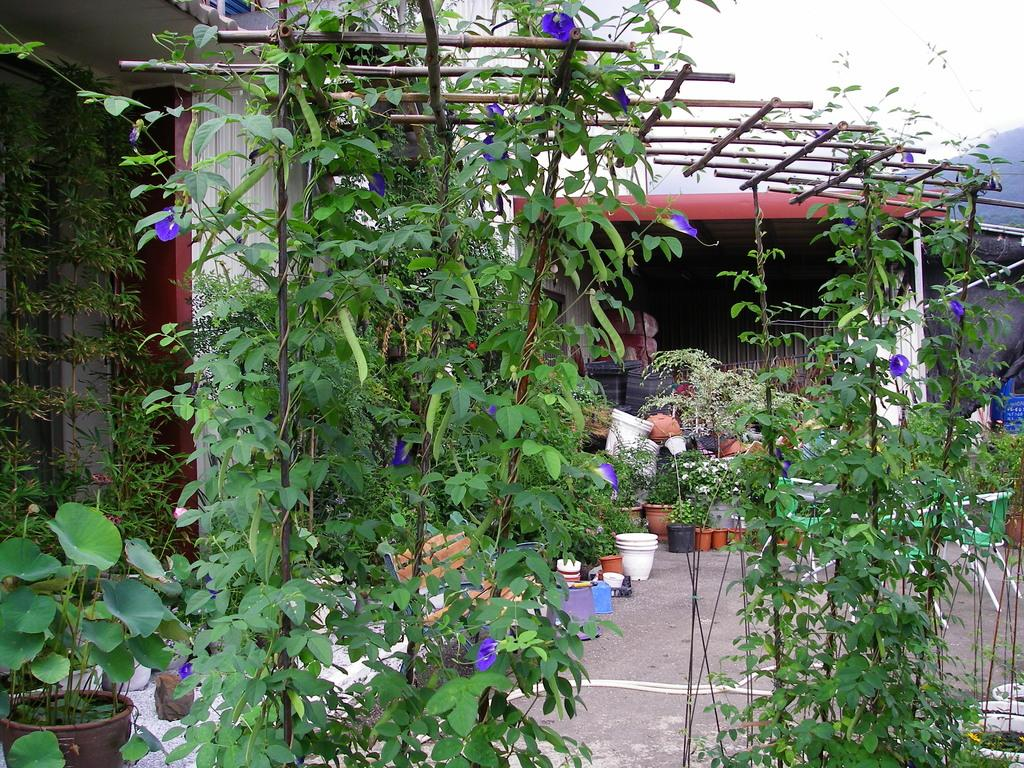What type of seating is present in the image? There is a bench in the image. What can be found on the ground near the bench? There are pots on the ground in the image. What is growing in the pots? There are plants in the image. What else can be seen in the image besides the bench and plants? There are sticks and objects visible in the background of the image. How many mice are balancing on the cat in the image? There is no cat or mice present in the image. What type of cat is sitting on the bench in the image? There is no cat present in the image; it features a bench, pots, plants, sticks, and objects in the background. 